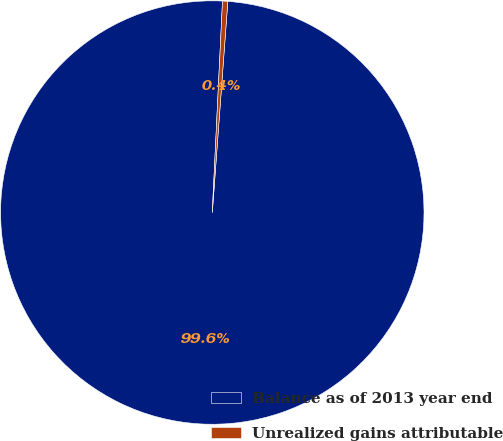Convert chart. <chart><loc_0><loc_0><loc_500><loc_500><pie_chart><fcel>Balance as of 2013 year end<fcel>Unrealized gains attributable<nl><fcel>99.6%<fcel>0.4%<nl></chart> 